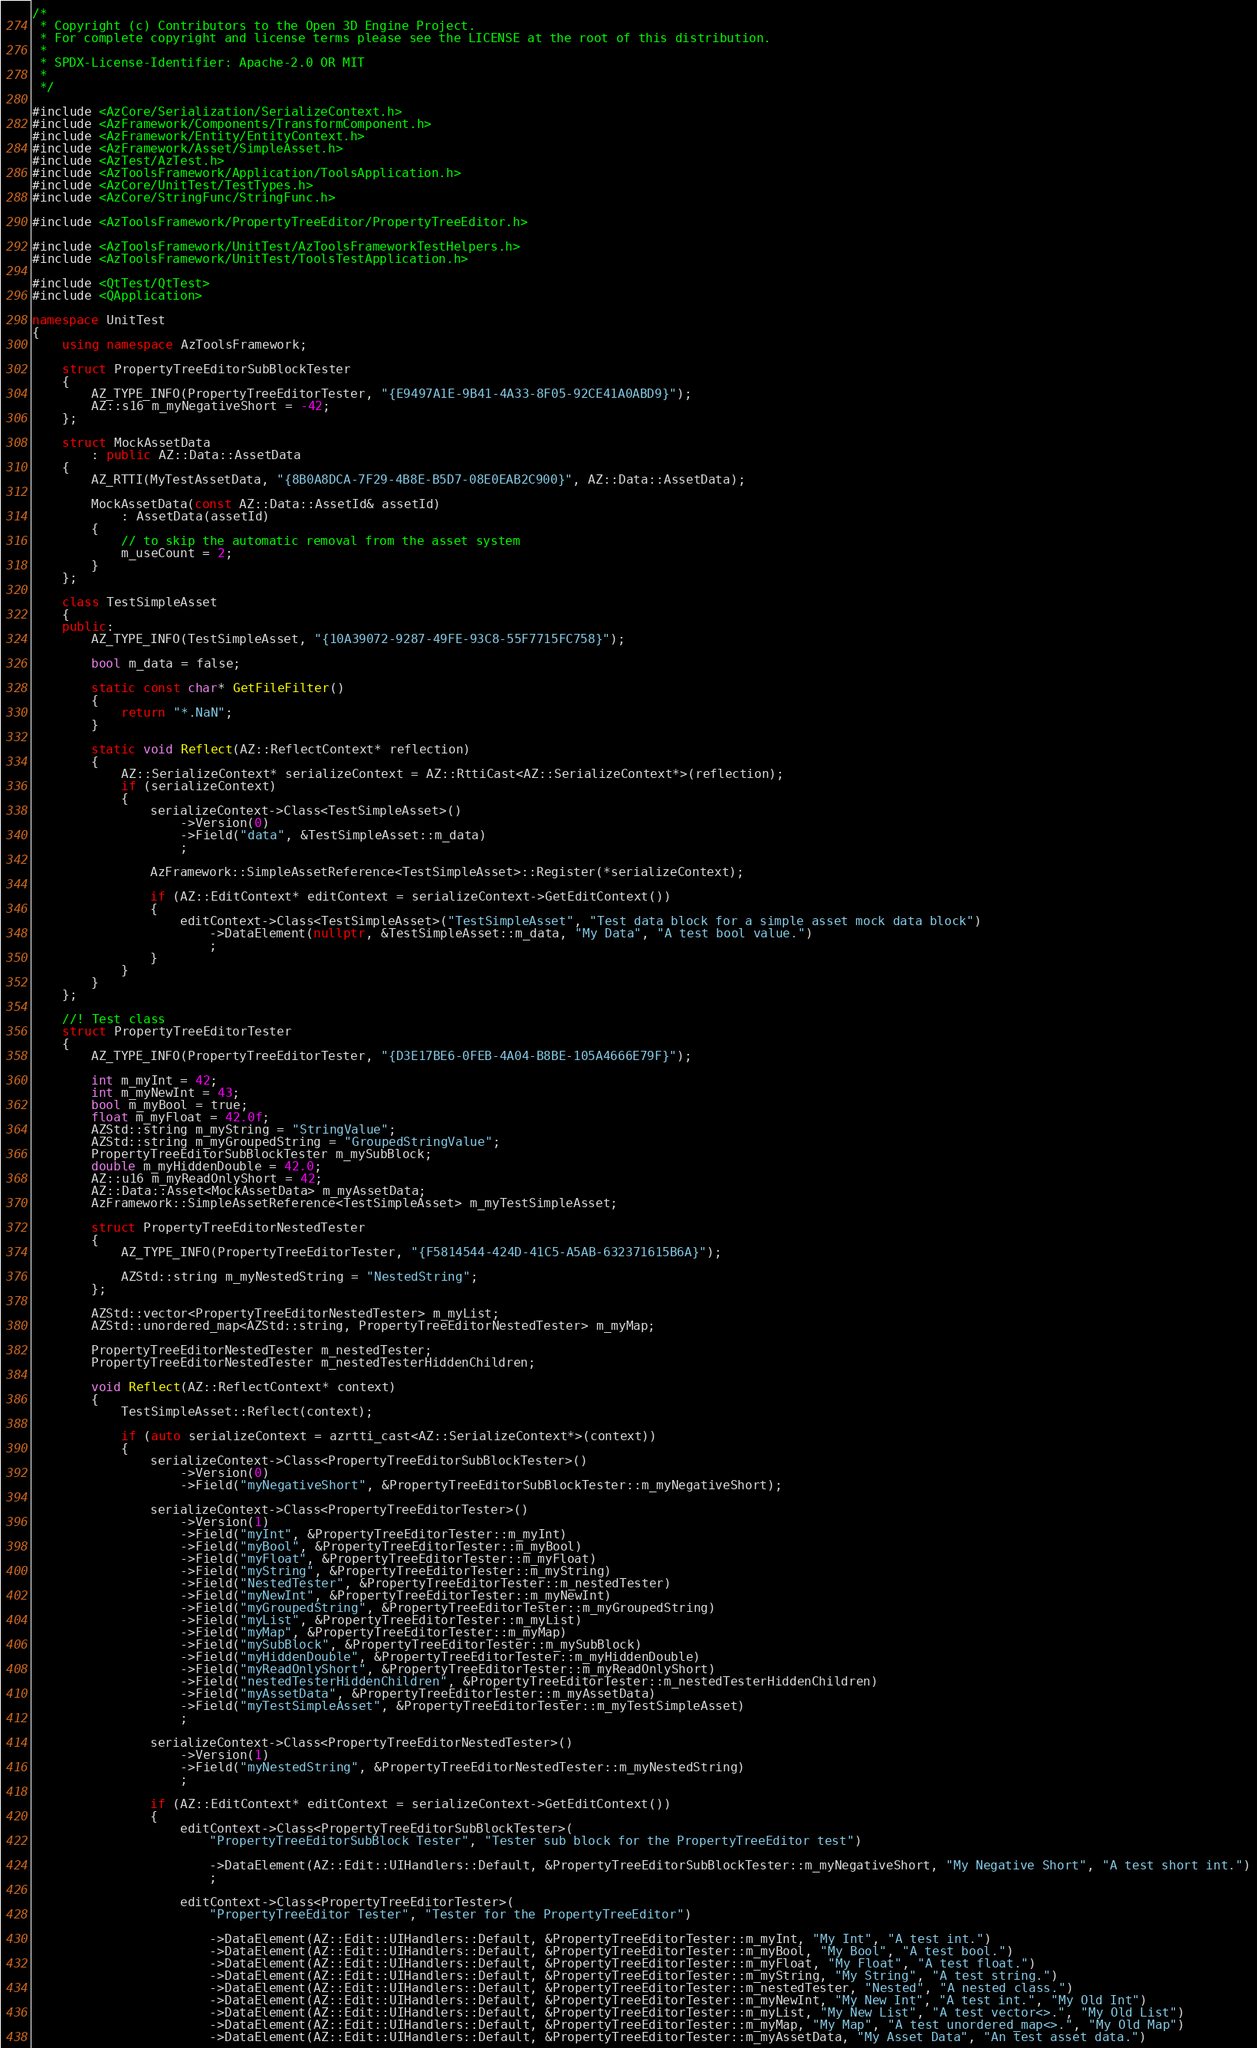Convert code to text. <code><loc_0><loc_0><loc_500><loc_500><_C++_>/*
 * Copyright (c) Contributors to the Open 3D Engine Project.
 * For complete copyright and license terms please see the LICENSE at the root of this distribution.
 *
 * SPDX-License-Identifier: Apache-2.0 OR MIT
 *
 */

#include <AzCore/Serialization/SerializeContext.h>
#include <AzFramework/Components/TransformComponent.h>
#include <AzFramework/Entity/EntityContext.h>
#include <AzFramework/Asset/SimpleAsset.h>
#include <AzTest/AzTest.h>
#include <AzToolsFramework/Application/ToolsApplication.h>
#include <AzCore/UnitTest/TestTypes.h>
#include <AzCore/StringFunc/StringFunc.h>

#include <AzToolsFramework/PropertyTreeEditor/PropertyTreeEditor.h>

#include <AzToolsFramework/UnitTest/AzToolsFrameworkTestHelpers.h>
#include <AzToolsFramework/UnitTest/ToolsTestApplication.h>

#include <QtTest/QtTest>
#include <QApplication>

namespace UnitTest
{
    using namespace AzToolsFramework;

    struct PropertyTreeEditorSubBlockTester
    {
        AZ_TYPE_INFO(PropertyTreeEditorTester, "{E9497A1E-9B41-4A33-8F05-92CE41A0ABD9}");
        AZ::s16 m_myNegativeShort = -42;
    };

    struct MockAssetData
        : public AZ::Data::AssetData
    {
        AZ_RTTI(MyTestAssetData, "{8B0A8DCA-7F29-4B8E-B5D7-08E0EAB2C900}", AZ::Data::AssetData);

        MockAssetData(const AZ::Data::AssetId& assetId)
            : AssetData(assetId)
        {
            // to skip the automatic removal from the asset system
            m_useCount = 2;
        }
    };

    class TestSimpleAsset
    {
    public:
        AZ_TYPE_INFO(TestSimpleAsset, "{10A39072-9287-49FE-93C8-55F7715FC758}");

        bool m_data = false;

        static const char* GetFileFilter()
        {
            return "*.NaN";
        }

        static void Reflect(AZ::ReflectContext* reflection)
        {
            AZ::SerializeContext* serializeContext = AZ::RttiCast<AZ::SerializeContext*>(reflection);
            if (serializeContext)
            {
                serializeContext->Class<TestSimpleAsset>()
                    ->Version(0)
                    ->Field("data", &TestSimpleAsset::m_data)
                    ;

                AzFramework::SimpleAssetReference<TestSimpleAsset>::Register(*serializeContext);

                if (AZ::EditContext* editContext = serializeContext->GetEditContext())
                {
                    editContext->Class<TestSimpleAsset>("TestSimpleAsset", "Test data block for a simple asset mock data block")
                        ->DataElement(nullptr, &TestSimpleAsset::m_data, "My Data", "A test bool value.")
                        ;
                }
            }
        }
    };

    //! Test class
    struct PropertyTreeEditorTester
    {
        AZ_TYPE_INFO(PropertyTreeEditorTester, "{D3E17BE6-0FEB-4A04-B8BE-105A4666E79F}");

        int m_myInt = 42;
        int m_myNewInt = 43;
        bool m_myBool = true;
        float m_myFloat = 42.0f;
        AZStd::string m_myString = "StringValue";
        AZStd::string m_myGroupedString = "GroupedStringValue";
        PropertyTreeEditorSubBlockTester m_mySubBlock;
        double m_myHiddenDouble = 42.0;
        AZ::u16 m_myReadOnlyShort = 42;
        AZ::Data::Asset<MockAssetData> m_myAssetData;
        AzFramework::SimpleAssetReference<TestSimpleAsset> m_myTestSimpleAsset;

        struct PropertyTreeEditorNestedTester
        {
            AZ_TYPE_INFO(PropertyTreeEditorTester, "{F5814544-424D-41C5-A5AB-632371615B6A}");

            AZStd::string m_myNestedString = "NestedString";
        };

        AZStd::vector<PropertyTreeEditorNestedTester> m_myList;
        AZStd::unordered_map<AZStd::string, PropertyTreeEditorNestedTester> m_myMap;

        PropertyTreeEditorNestedTester m_nestedTester;
        PropertyTreeEditorNestedTester m_nestedTesterHiddenChildren;

        void Reflect(AZ::ReflectContext* context)
        {
            TestSimpleAsset::Reflect(context);

            if (auto serializeContext = azrtti_cast<AZ::SerializeContext*>(context))
            {
                serializeContext->Class<PropertyTreeEditorSubBlockTester>()
                    ->Version(0)
                    ->Field("myNegativeShort", &PropertyTreeEditorSubBlockTester::m_myNegativeShort);

                serializeContext->Class<PropertyTreeEditorTester>()
                    ->Version(1)
                    ->Field("myInt", &PropertyTreeEditorTester::m_myInt)
                    ->Field("myBool", &PropertyTreeEditorTester::m_myBool)
                    ->Field("myFloat", &PropertyTreeEditorTester::m_myFloat)
                    ->Field("myString", &PropertyTreeEditorTester::m_myString)
                    ->Field("NestedTester", &PropertyTreeEditorTester::m_nestedTester)
                    ->Field("myNewInt", &PropertyTreeEditorTester::m_myNewInt)
                    ->Field("myGroupedString", &PropertyTreeEditorTester::m_myGroupedString)
                    ->Field("myList", &PropertyTreeEditorTester::m_myList)
                    ->Field("myMap", &PropertyTreeEditorTester::m_myMap)
                    ->Field("mySubBlock", &PropertyTreeEditorTester::m_mySubBlock)
                    ->Field("myHiddenDouble", &PropertyTreeEditorTester::m_myHiddenDouble)
                    ->Field("myReadOnlyShort", &PropertyTreeEditorTester::m_myReadOnlyShort)                    
                    ->Field("nestedTesterHiddenChildren", &PropertyTreeEditorTester::m_nestedTesterHiddenChildren)
                    ->Field("myAssetData", &PropertyTreeEditorTester::m_myAssetData)
                    ->Field("myTestSimpleAsset", &PropertyTreeEditorTester::m_myTestSimpleAsset)
                    ;

                serializeContext->Class<PropertyTreeEditorNestedTester>()
                    ->Version(1)
                    ->Field("myNestedString", &PropertyTreeEditorNestedTester::m_myNestedString)
                    ;

                if (AZ::EditContext* editContext = serializeContext->GetEditContext())
                {
                    editContext->Class<PropertyTreeEditorSubBlockTester>(
                        "PropertyTreeEditorSubBlock Tester", "Tester sub block for the PropertyTreeEditor test")

                        ->DataElement(AZ::Edit::UIHandlers::Default, &PropertyTreeEditorSubBlockTester::m_myNegativeShort, "My Negative Short", "A test short int.")
                        ;

                    editContext->Class<PropertyTreeEditorTester>(
                        "PropertyTreeEditor Tester", "Tester for the PropertyTreeEditor")

                        ->DataElement(AZ::Edit::UIHandlers::Default, &PropertyTreeEditorTester::m_myInt, "My Int", "A test int.")
                        ->DataElement(AZ::Edit::UIHandlers::Default, &PropertyTreeEditorTester::m_myBool, "My Bool", "A test bool.")
                        ->DataElement(AZ::Edit::UIHandlers::Default, &PropertyTreeEditorTester::m_myFloat, "My Float", "A test float.")
                        ->DataElement(AZ::Edit::UIHandlers::Default, &PropertyTreeEditorTester::m_myString, "My String", "A test string.")
                        ->DataElement(AZ::Edit::UIHandlers::Default, &PropertyTreeEditorTester::m_nestedTester, "Nested", "A nested class.")
                        ->DataElement(AZ::Edit::UIHandlers::Default, &PropertyTreeEditorTester::m_myNewInt, "My New Int", "A test int.", "My Old Int")
                        ->DataElement(AZ::Edit::UIHandlers::Default, &PropertyTreeEditorTester::m_myList, "My New List", "A test vector<>.", "My Old List")
                        ->DataElement(AZ::Edit::UIHandlers::Default, &PropertyTreeEditorTester::m_myMap, "My Map", "A test unordered_map<>.", "My Old Map")
                        ->DataElement(AZ::Edit::UIHandlers::Default, &PropertyTreeEditorTester::m_myAssetData, "My Asset Data", "An test asset data.")</code> 